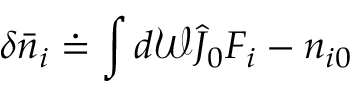Convert formula to latex. <formula><loc_0><loc_0><loc_500><loc_500>\delta \bar { n } _ { i } \doteq \int d \mathcal { W } \hat { J } _ { 0 } F _ { i } - n _ { i 0 }</formula> 